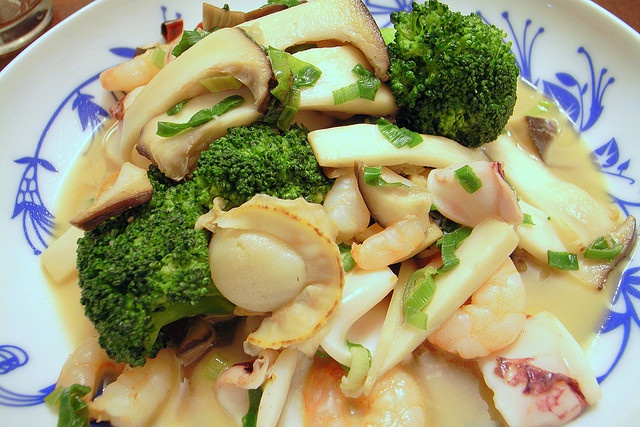Describe the objects in this image and their specific colors. I can see broccoli in olive, black, and darkgreen tones and broccoli in olive, black, and darkgreen tones in this image. 